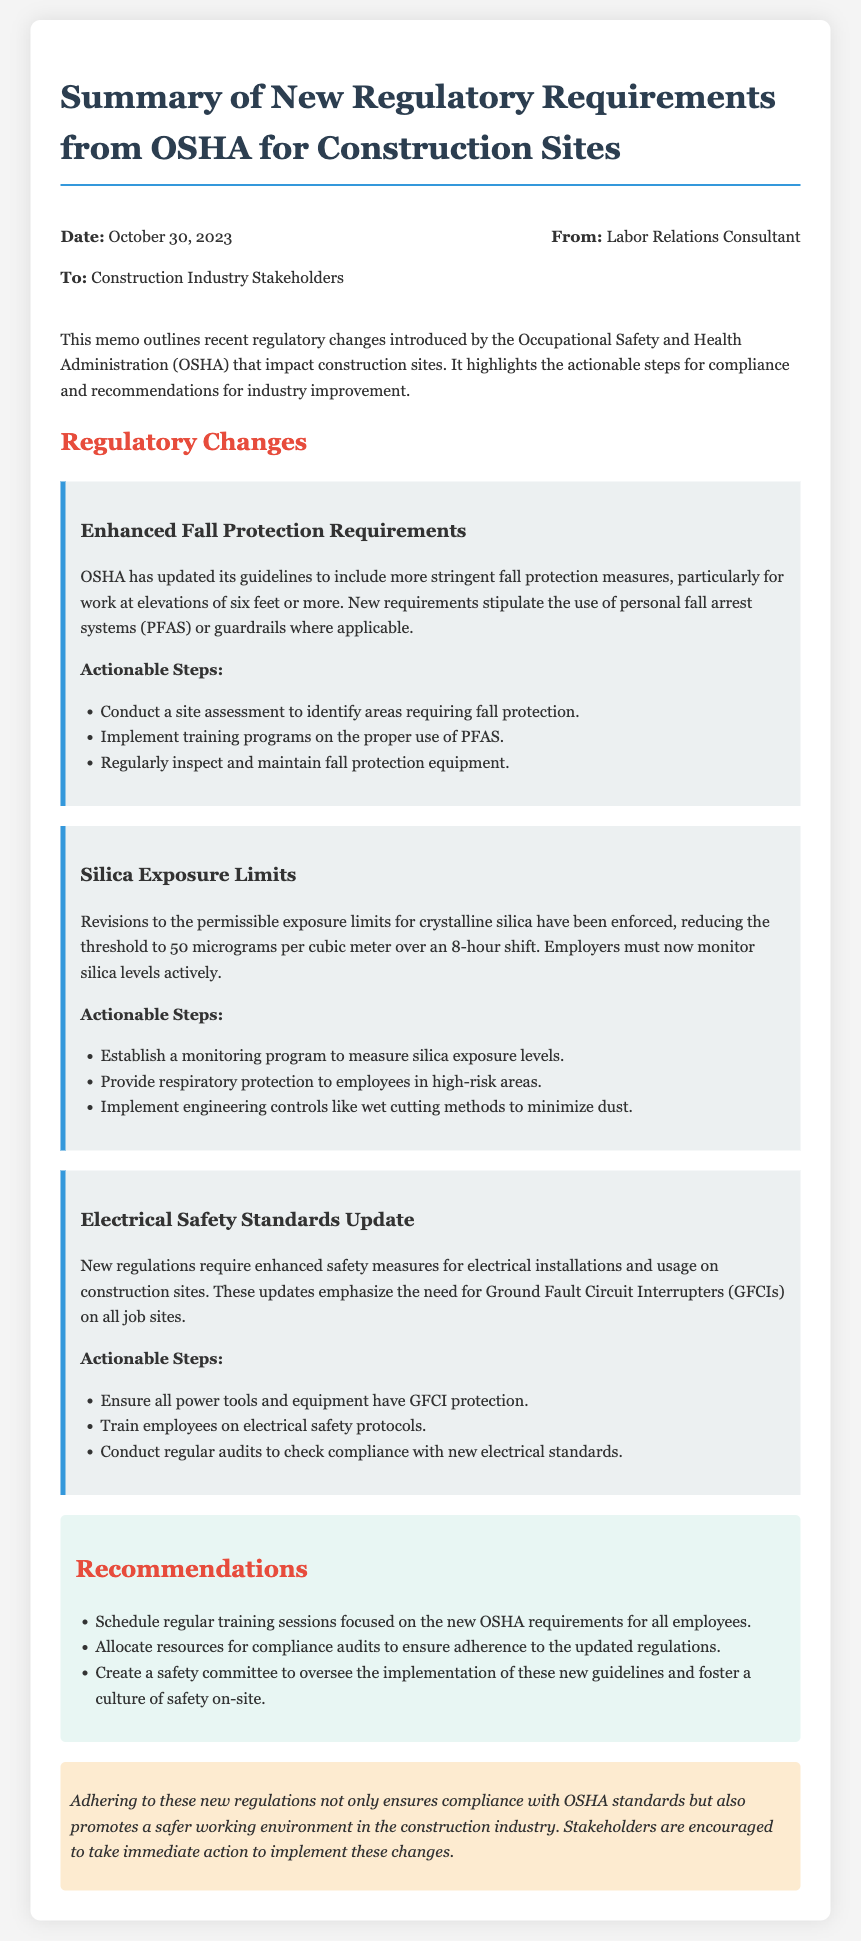What is the date of the memo? The date of the memo is mentioned clearly at the beginning, indicating when it was created.
Answer: October 30, 2023 Who is the memo addressed to? The memo specifies the recipients, which are the stakeholders in the construction industry.
Answer: Construction Industry Stakeholders What are the new permissible exposure limits for crystalline silica? The document outlines the exact limit that has been revised for silica exposure, which is critical for compliance.
Answer: 50 micrograms per cubic meter What does PFAS stand for? The memo introduces an abbreviation related to fall protection, which needs to be defined for clarity.
Answer: Personal Fall Arrest Systems What is one actionable step for enhanced fall protection? The document provides specific steps to comply with new fall protection regulations, highlighting important actions to take.
Answer: Conduct a site assessment to identify areas requiring fall protection What recommendation is made regarding training sessions? The memo suggests a course of action that emphasizes the importance of training in response to new regulations.
Answer: Schedule regular training sessions focused on the new OSHA requirements for all employees What is one required safety feature for electrical installations? The updated regulations necessitate a specific component to ensure safety in electrical usage on construction sites, which is a major compliance aspect.
Answer: Ground Fault Circuit Interrupters (GFCIs) What is the overall purpose of adhering to the new regulations? The conclusion of the memo summarizes the importance of these regulations beyond just compliance.
Answer: Promote a safer working environment in the construction industry 